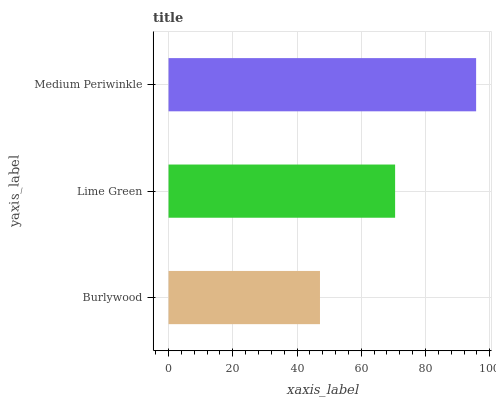Is Burlywood the minimum?
Answer yes or no. Yes. Is Medium Periwinkle the maximum?
Answer yes or no. Yes. Is Lime Green the minimum?
Answer yes or no. No. Is Lime Green the maximum?
Answer yes or no. No. Is Lime Green greater than Burlywood?
Answer yes or no. Yes. Is Burlywood less than Lime Green?
Answer yes or no. Yes. Is Burlywood greater than Lime Green?
Answer yes or no. No. Is Lime Green less than Burlywood?
Answer yes or no. No. Is Lime Green the high median?
Answer yes or no. Yes. Is Lime Green the low median?
Answer yes or no. Yes. Is Medium Periwinkle the high median?
Answer yes or no. No. Is Burlywood the low median?
Answer yes or no. No. 